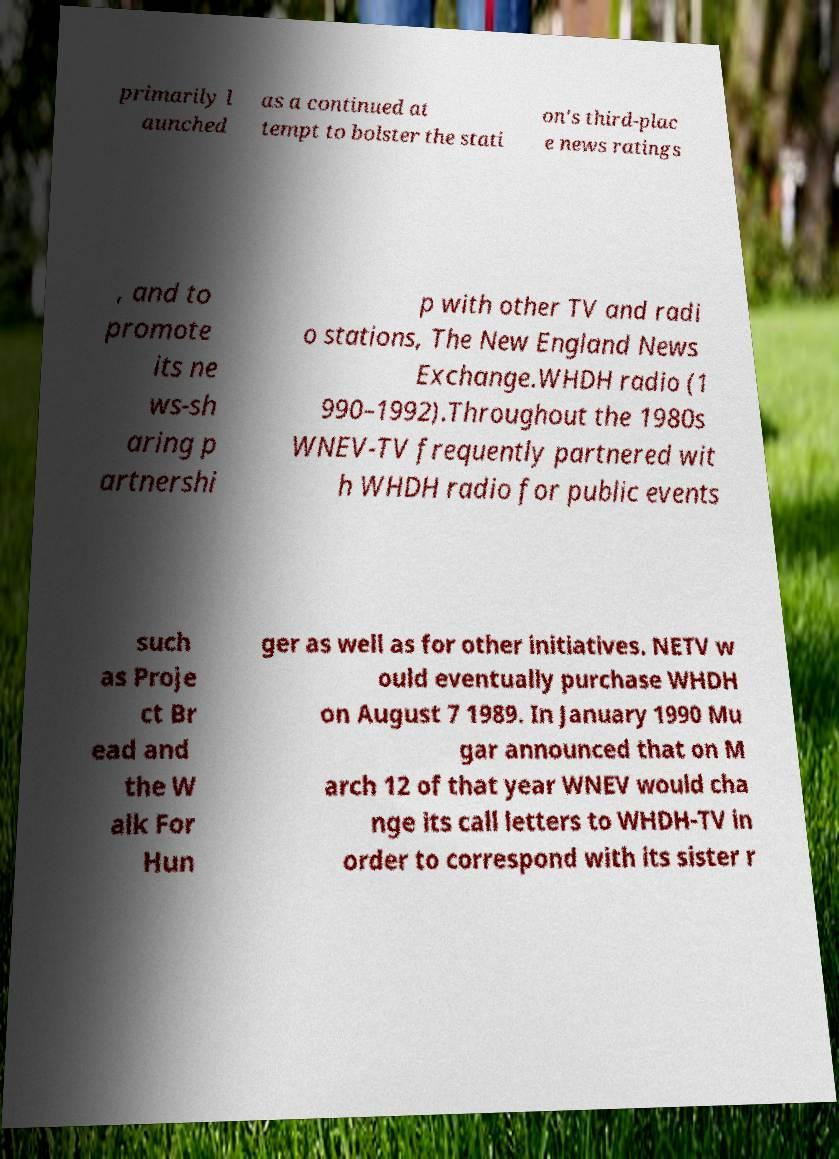For documentation purposes, I need the text within this image transcribed. Could you provide that? primarily l aunched as a continued at tempt to bolster the stati on's third-plac e news ratings , and to promote its ne ws-sh aring p artnershi p with other TV and radi o stations, The New England News Exchange.WHDH radio (1 990–1992).Throughout the 1980s WNEV-TV frequently partnered wit h WHDH radio for public events such as Proje ct Br ead and the W alk For Hun ger as well as for other initiatives. NETV w ould eventually purchase WHDH on August 7 1989. In January 1990 Mu gar announced that on M arch 12 of that year WNEV would cha nge its call letters to WHDH-TV in order to correspond with its sister r 